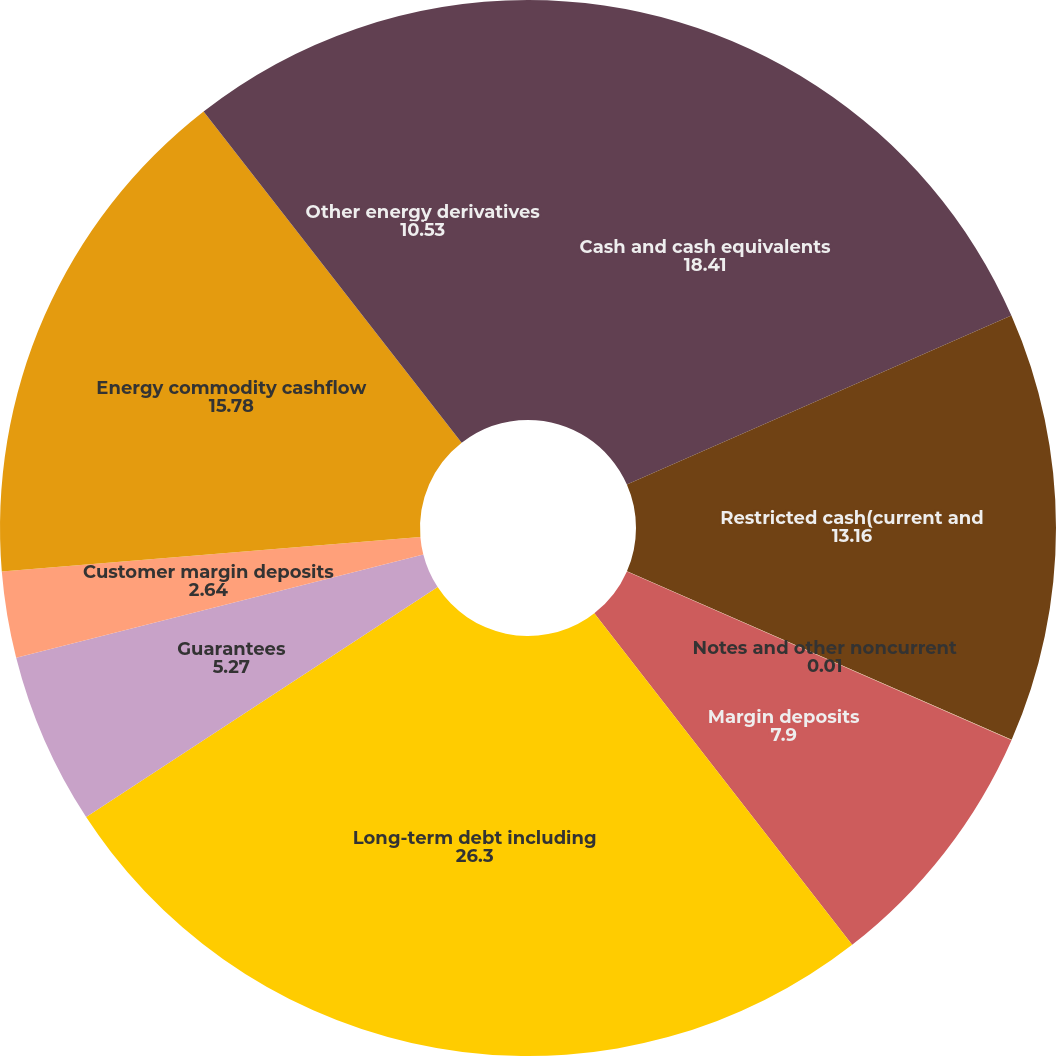Convert chart to OTSL. <chart><loc_0><loc_0><loc_500><loc_500><pie_chart><fcel>Cash and cash equivalents<fcel>Restricted cash(current and<fcel>Notes and other noncurrent<fcel>Margin deposits<fcel>Long-term debt including<fcel>Guarantees<fcel>Customer margin deposits<fcel>Energy commodity cashflow<fcel>Other energy derivatives<nl><fcel>18.41%<fcel>13.16%<fcel>0.01%<fcel>7.9%<fcel>26.3%<fcel>5.27%<fcel>2.64%<fcel>15.78%<fcel>10.53%<nl></chart> 